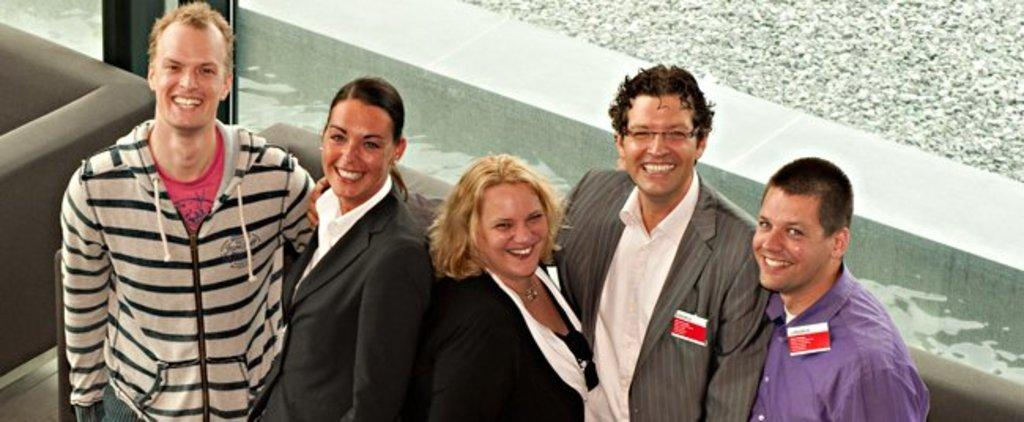How many people are in the image? There is a group of people standing in the image. What type of furniture is present in the image? There are two couches in the image. What is the background feature behind the persons in the image? There is a glass wall behind the persons in the image. Can you see any goldfish swimming in the image? There are no goldfish present in the image. Is there a cook preparing food in the image? There is no cook or food preparation visible in the image. 